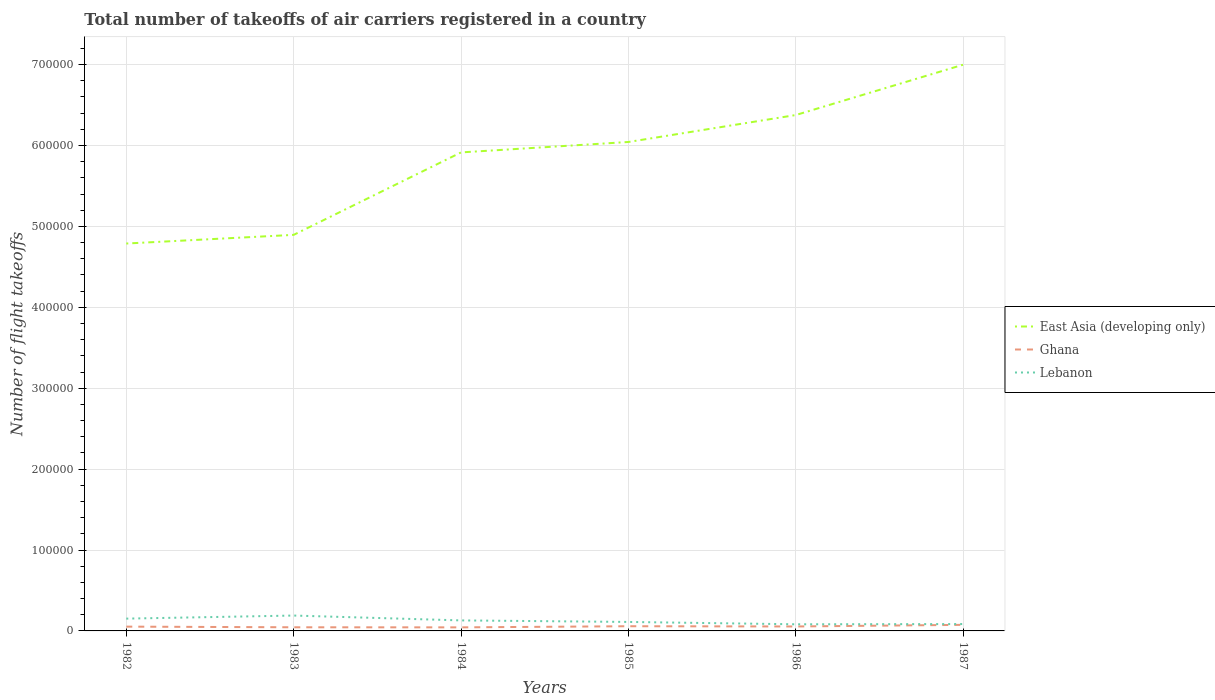Does the line corresponding to East Asia (developing only) intersect with the line corresponding to Lebanon?
Provide a short and direct response. No. Is the number of lines equal to the number of legend labels?
Give a very brief answer. Yes. Across all years, what is the maximum total number of flight takeoffs in East Asia (developing only)?
Ensure brevity in your answer.  4.79e+05. In which year was the total number of flight takeoffs in Lebanon maximum?
Give a very brief answer. 1986. What is the total total number of flight takeoffs in Ghana in the graph?
Your answer should be very brief. -3000. What is the difference between the highest and the second highest total number of flight takeoffs in East Asia (developing only)?
Offer a terse response. 2.21e+05. What is the difference between the highest and the lowest total number of flight takeoffs in Ghana?
Offer a very short reply. 2. Is the total number of flight takeoffs in Ghana strictly greater than the total number of flight takeoffs in East Asia (developing only) over the years?
Give a very brief answer. Yes. How many years are there in the graph?
Offer a very short reply. 6. What is the difference between two consecutive major ticks on the Y-axis?
Give a very brief answer. 1.00e+05. Are the values on the major ticks of Y-axis written in scientific E-notation?
Keep it short and to the point. No. Where does the legend appear in the graph?
Your answer should be very brief. Center right. How are the legend labels stacked?
Your response must be concise. Vertical. What is the title of the graph?
Offer a terse response. Total number of takeoffs of air carriers registered in a country. Does "Swaziland" appear as one of the legend labels in the graph?
Your answer should be compact. No. What is the label or title of the X-axis?
Your response must be concise. Years. What is the label or title of the Y-axis?
Keep it short and to the point. Number of flight takeoffs. What is the Number of flight takeoffs of East Asia (developing only) in 1982?
Keep it short and to the point. 4.79e+05. What is the Number of flight takeoffs of Ghana in 1982?
Make the answer very short. 5300. What is the Number of flight takeoffs in Lebanon in 1982?
Your answer should be very brief. 1.52e+04. What is the Number of flight takeoffs in East Asia (developing only) in 1983?
Provide a short and direct response. 4.90e+05. What is the Number of flight takeoffs in Ghana in 1983?
Provide a short and direct response. 4500. What is the Number of flight takeoffs in Lebanon in 1983?
Your response must be concise. 1.90e+04. What is the Number of flight takeoffs of East Asia (developing only) in 1984?
Keep it short and to the point. 5.91e+05. What is the Number of flight takeoffs in Ghana in 1984?
Provide a short and direct response. 4400. What is the Number of flight takeoffs of Lebanon in 1984?
Your answer should be compact. 1.30e+04. What is the Number of flight takeoffs in East Asia (developing only) in 1985?
Offer a very short reply. 6.04e+05. What is the Number of flight takeoffs in Ghana in 1985?
Your answer should be compact. 5800. What is the Number of flight takeoffs of Lebanon in 1985?
Give a very brief answer. 1.11e+04. What is the Number of flight takeoffs of East Asia (developing only) in 1986?
Your response must be concise. 6.38e+05. What is the Number of flight takeoffs of Ghana in 1986?
Provide a succinct answer. 5500. What is the Number of flight takeoffs in Lebanon in 1986?
Make the answer very short. 8200. What is the Number of flight takeoffs in East Asia (developing only) in 1987?
Your answer should be compact. 7.00e+05. What is the Number of flight takeoffs of Ghana in 1987?
Your answer should be compact. 7500. What is the Number of flight takeoffs of Lebanon in 1987?
Give a very brief answer. 8500. Across all years, what is the maximum Number of flight takeoffs of East Asia (developing only)?
Your response must be concise. 7.00e+05. Across all years, what is the maximum Number of flight takeoffs of Ghana?
Your response must be concise. 7500. Across all years, what is the maximum Number of flight takeoffs in Lebanon?
Your response must be concise. 1.90e+04. Across all years, what is the minimum Number of flight takeoffs in East Asia (developing only)?
Make the answer very short. 4.79e+05. Across all years, what is the minimum Number of flight takeoffs in Ghana?
Keep it short and to the point. 4400. Across all years, what is the minimum Number of flight takeoffs of Lebanon?
Ensure brevity in your answer.  8200. What is the total Number of flight takeoffs of East Asia (developing only) in the graph?
Offer a very short reply. 3.50e+06. What is the total Number of flight takeoffs of Ghana in the graph?
Offer a terse response. 3.30e+04. What is the total Number of flight takeoffs of Lebanon in the graph?
Keep it short and to the point. 7.50e+04. What is the difference between the Number of flight takeoffs in East Asia (developing only) in 1982 and that in 1983?
Keep it short and to the point. -1.07e+04. What is the difference between the Number of flight takeoffs of Ghana in 1982 and that in 1983?
Keep it short and to the point. 800. What is the difference between the Number of flight takeoffs of Lebanon in 1982 and that in 1983?
Give a very brief answer. -3800. What is the difference between the Number of flight takeoffs in East Asia (developing only) in 1982 and that in 1984?
Your response must be concise. -1.13e+05. What is the difference between the Number of flight takeoffs in Ghana in 1982 and that in 1984?
Provide a succinct answer. 900. What is the difference between the Number of flight takeoffs of Lebanon in 1982 and that in 1984?
Ensure brevity in your answer.  2200. What is the difference between the Number of flight takeoffs in East Asia (developing only) in 1982 and that in 1985?
Give a very brief answer. -1.26e+05. What is the difference between the Number of flight takeoffs of Ghana in 1982 and that in 1985?
Give a very brief answer. -500. What is the difference between the Number of flight takeoffs of Lebanon in 1982 and that in 1985?
Ensure brevity in your answer.  4100. What is the difference between the Number of flight takeoffs of East Asia (developing only) in 1982 and that in 1986?
Your answer should be compact. -1.59e+05. What is the difference between the Number of flight takeoffs in Ghana in 1982 and that in 1986?
Your answer should be compact. -200. What is the difference between the Number of flight takeoffs in Lebanon in 1982 and that in 1986?
Keep it short and to the point. 7000. What is the difference between the Number of flight takeoffs of East Asia (developing only) in 1982 and that in 1987?
Your response must be concise. -2.21e+05. What is the difference between the Number of flight takeoffs in Ghana in 1982 and that in 1987?
Offer a very short reply. -2200. What is the difference between the Number of flight takeoffs of Lebanon in 1982 and that in 1987?
Your response must be concise. 6700. What is the difference between the Number of flight takeoffs in East Asia (developing only) in 1983 and that in 1984?
Your response must be concise. -1.02e+05. What is the difference between the Number of flight takeoffs of Ghana in 1983 and that in 1984?
Provide a short and direct response. 100. What is the difference between the Number of flight takeoffs in Lebanon in 1983 and that in 1984?
Provide a short and direct response. 6000. What is the difference between the Number of flight takeoffs in East Asia (developing only) in 1983 and that in 1985?
Provide a short and direct response. -1.15e+05. What is the difference between the Number of flight takeoffs of Ghana in 1983 and that in 1985?
Your answer should be compact. -1300. What is the difference between the Number of flight takeoffs of Lebanon in 1983 and that in 1985?
Your response must be concise. 7900. What is the difference between the Number of flight takeoffs in East Asia (developing only) in 1983 and that in 1986?
Give a very brief answer. -1.48e+05. What is the difference between the Number of flight takeoffs in Ghana in 1983 and that in 1986?
Provide a short and direct response. -1000. What is the difference between the Number of flight takeoffs in Lebanon in 1983 and that in 1986?
Provide a short and direct response. 1.08e+04. What is the difference between the Number of flight takeoffs of East Asia (developing only) in 1983 and that in 1987?
Provide a succinct answer. -2.10e+05. What is the difference between the Number of flight takeoffs in Ghana in 1983 and that in 1987?
Offer a terse response. -3000. What is the difference between the Number of flight takeoffs in Lebanon in 1983 and that in 1987?
Give a very brief answer. 1.05e+04. What is the difference between the Number of flight takeoffs of East Asia (developing only) in 1984 and that in 1985?
Give a very brief answer. -1.29e+04. What is the difference between the Number of flight takeoffs in Ghana in 1984 and that in 1985?
Give a very brief answer. -1400. What is the difference between the Number of flight takeoffs of Lebanon in 1984 and that in 1985?
Offer a very short reply. 1900. What is the difference between the Number of flight takeoffs of East Asia (developing only) in 1984 and that in 1986?
Ensure brevity in your answer.  -4.62e+04. What is the difference between the Number of flight takeoffs in Ghana in 1984 and that in 1986?
Give a very brief answer. -1100. What is the difference between the Number of flight takeoffs in Lebanon in 1984 and that in 1986?
Offer a terse response. 4800. What is the difference between the Number of flight takeoffs in East Asia (developing only) in 1984 and that in 1987?
Provide a short and direct response. -1.08e+05. What is the difference between the Number of flight takeoffs in Ghana in 1984 and that in 1987?
Provide a succinct answer. -3100. What is the difference between the Number of flight takeoffs in Lebanon in 1984 and that in 1987?
Offer a terse response. 4500. What is the difference between the Number of flight takeoffs of East Asia (developing only) in 1985 and that in 1986?
Offer a very short reply. -3.33e+04. What is the difference between the Number of flight takeoffs in Ghana in 1985 and that in 1986?
Provide a succinct answer. 300. What is the difference between the Number of flight takeoffs of Lebanon in 1985 and that in 1986?
Your response must be concise. 2900. What is the difference between the Number of flight takeoffs of East Asia (developing only) in 1985 and that in 1987?
Provide a short and direct response. -9.55e+04. What is the difference between the Number of flight takeoffs in Ghana in 1985 and that in 1987?
Your answer should be very brief. -1700. What is the difference between the Number of flight takeoffs in Lebanon in 1985 and that in 1987?
Offer a very short reply. 2600. What is the difference between the Number of flight takeoffs in East Asia (developing only) in 1986 and that in 1987?
Give a very brief answer. -6.22e+04. What is the difference between the Number of flight takeoffs in Ghana in 1986 and that in 1987?
Your answer should be compact. -2000. What is the difference between the Number of flight takeoffs in Lebanon in 1986 and that in 1987?
Make the answer very short. -300. What is the difference between the Number of flight takeoffs of East Asia (developing only) in 1982 and the Number of flight takeoffs of Ghana in 1983?
Offer a terse response. 4.74e+05. What is the difference between the Number of flight takeoffs in East Asia (developing only) in 1982 and the Number of flight takeoffs in Lebanon in 1983?
Provide a succinct answer. 4.60e+05. What is the difference between the Number of flight takeoffs in Ghana in 1982 and the Number of flight takeoffs in Lebanon in 1983?
Offer a terse response. -1.37e+04. What is the difference between the Number of flight takeoffs of East Asia (developing only) in 1982 and the Number of flight takeoffs of Ghana in 1984?
Your response must be concise. 4.74e+05. What is the difference between the Number of flight takeoffs in East Asia (developing only) in 1982 and the Number of flight takeoffs in Lebanon in 1984?
Offer a terse response. 4.66e+05. What is the difference between the Number of flight takeoffs of Ghana in 1982 and the Number of flight takeoffs of Lebanon in 1984?
Ensure brevity in your answer.  -7700. What is the difference between the Number of flight takeoffs in East Asia (developing only) in 1982 and the Number of flight takeoffs in Ghana in 1985?
Keep it short and to the point. 4.73e+05. What is the difference between the Number of flight takeoffs in East Asia (developing only) in 1982 and the Number of flight takeoffs in Lebanon in 1985?
Offer a very short reply. 4.68e+05. What is the difference between the Number of flight takeoffs in Ghana in 1982 and the Number of flight takeoffs in Lebanon in 1985?
Your answer should be very brief. -5800. What is the difference between the Number of flight takeoffs in East Asia (developing only) in 1982 and the Number of flight takeoffs in Ghana in 1986?
Your answer should be compact. 4.73e+05. What is the difference between the Number of flight takeoffs of East Asia (developing only) in 1982 and the Number of flight takeoffs of Lebanon in 1986?
Provide a short and direct response. 4.71e+05. What is the difference between the Number of flight takeoffs in Ghana in 1982 and the Number of flight takeoffs in Lebanon in 1986?
Provide a short and direct response. -2900. What is the difference between the Number of flight takeoffs of East Asia (developing only) in 1982 and the Number of flight takeoffs of Ghana in 1987?
Keep it short and to the point. 4.71e+05. What is the difference between the Number of flight takeoffs of East Asia (developing only) in 1982 and the Number of flight takeoffs of Lebanon in 1987?
Give a very brief answer. 4.70e+05. What is the difference between the Number of flight takeoffs of Ghana in 1982 and the Number of flight takeoffs of Lebanon in 1987?
Your answer should be compact. -3200. What is the difference between the Number of flight takeoffs of East Asia (developing only) in 1983 and the Number of flight takeoffs of Ghana in 1984?
Give a very brief answer. 4.85e+05. What is the difference between the Number of flight takeoffs of East Asia (developing only) in 1983 and the Number of flight takeoffs of Lebanon in 1984?
Ensure brevity in your answer.  4.76e+05. What is the difference between the Number of flight takeoffs in Ghana in 1983 and the Number of flight takeoffs in Lebanon in 1984?
Make the answer very short. -8500. What is the difference between the Number of flight takeoffs in East Asia (developing only) in 1983 and the Number of flight takeoffs in Ghana in 1985?
Provide a succinct answer. 4.84e+05. What is the difference between the Number of flight takeoffs in East Asia (developing only) in 1983 and the Number of flight takeoffs in Lebanon in 1985?
Offer a terse response. 4.78e+05. What is the difference between the Number of flight takeoffs of Ghana in 1983 and the Number of flight takeoffs of Lebanon in 1985?
Offer a terse response. -6600. What is the difference between the Number of flight takeoffs of East Asia (developing only) in 1983 and the Number of flight takeoffs of Ghana in 1986?
Provide a succinct answer. 4.84e+05. What is the difference between the Number of flight takeoffs in East Asia (developing only) in 1983 and the Number of flight takeoffs in Lebanon in 1986?
Make the answer very short. 4.81e+05. What is the difference between the Number of flight takeoffs in Ghana in 1983 and the Number of flight takeoffs in Lebanon in 1986?
Your answer should be very brief. -3700. What is the difference between the Number of flight takeoffs of East Asia (developing only) in 1983 and the Number of flight takeoffs of Ghana in 1987?
Offer a terse response. 4.82e+05. What is the difference between the Number of flight takeoffs in East Asia (developing only) in 1983 and the Number of flight takeoffs in Lebanon in 1987?
Your answer should be very brief. 4.81e+05. What is the difference between the Number of flight takeoffs in Ghana in 1983 and the Number of flight takeoffs in Lebanon in 1987?
Provide a short and direct response. -4000. What is the difference between the Number of flight takeoffs in East Asia (developing only) in 1984 and the Number of flight takeoffs in Ghana in 1985?
Make the answer very short. 5.86e+05. What is the difference between the Number of flight takeoffs of East Asia (developing only) in 1984 and the Number of flight takeoffs of Lebanon in 1985?
Ensure brevity in your answer.  5.80e+05. What is the difference between the Number of flight takeoffs of Ghana in 1984 and the Number of flight takeoffs of Lebanon in 1985?
Offer a very short reply. -6700. What is the difference between the Number of flight takeoffs of East Asia (developing only) in 1984 and the Number of flight takeoffs of Ghana in 1986?
Offer a very short reply. 5.86e+05. What is the difference between the Number of flight takeoffs of East Asia (developing only) in 1984 and the Number of flight takeoffs of Lebanon in 1986?
Provide a succinct answer. 5.83e+05. What is the difference between the Number of flight takeoffs in Ghana in 1984 and the Number of flight takeoffs in Lebanon in 1986?
Give a very brief answer. -3800. What is the difference between the Number of flight takeoffs in East Asia (developing only) in 1984 and the Number of flight takeoffs in Ghana in 1987?
Provide a succinct answer. 5.84e+05. What is the difference between the Number of flight takeoffs of East Asia (developing only) in 1984 and the Number of flight takeoffs of Lebanon in 1987?
Ensure brevity in your answer.  5.83e+05. What is the difference between the Number of flight takeoffs in Ghana in 1984 and the Number of flight takeoffs in Lebanon in 1987?
Provide a short and direct response. -4100. What is the difference between the Number of flight takeoffs of East Asia (developing only) in 1985 and the Number of flight takeoffs of Ghana in 1986?
Make the answer very short. 5.99e+05. What is the difference between the Number of flight takeoffs of East Asia (developing only) in 1985 and the Number of flight takeoffs of Lebanon in 1986?
Keep it short and to the point. 5.96e+05. What is the difference between the Number of flight takeoffs of Ghana in 1985 and the Number of flight takeoffs of Lebanon in 1986?
Offer a very short reply. -2400. What is the difference between the Number of flight takeoffs in East Asia (developing only) in 1985 and the Number of flight takeoffs in Ghana in 1987?
Your response must be concise. 5.97e+05. What is the difference between the Number of flight takeoffs of East Asia (developing only) in 1985 and the Number of flight takeoffs of Lebanon in 1987?
Your answer should be very brief. 5.96e+05. What is the difference between the Number of flight takeoffs of Ghana in 1985 and the Number of flight takeoffs of Lebanon in 1987?
Keep it short and to the point. -2700. What is the difference between the Number of flight takeoffs of East Asia (developing only) in 1986 and the Number of flight takeoffs of Ghana in 1987?
Offer a terse response. 6.30e+05. What is the difference between the Number of flight takeoffs in East Asia (developing only) in 1986 and the Number of flight takeoffs in Lebanon in 1987?
Offer a very short reply. 6.29e+05. What is the difference between the Number of flight takeoffs of Ghana in 1986 and the Number of flight takeoffs of Lebanon in 1987?
Provide a short and direct response. -3000. What is the average Number of flight takeoffs in East Asia (developing only) per year?
Provide a succinct answer. 5.84e+05. What is the average Number of flight takeoffs of Ghana per year?
Provide a succinct answer. 5500. What is the average Number of flight takeoffs in Lebanon per year?
Give a very brief answer. 1.25e+04. In the year 1982, what is the difference between the Number of flight takeoffs in East Asia (developing only) and Number of flight takeoffs in Ghana?
Provide a succinct answer. 4.74e+05. In the year 1982, what is the difference between the Number of flight takeoffs of East Asia (developing only) and Number of flight takeoffs of Lebanon?
Ensure brevity in your answer.  4.64e+05. In the year 1982, what is the difference between the Number of flight takeoffs in Ghana and Number of flight takeoffs in Lebanon?
Your answer should be very brief. -9900. In the year 1983, what is the difference between the Number of flight takeoffs in East Asia (developing only) and Number of flight takeoffs in Ghana?
Your answer should be compact. 4.85e+05. In the year 1983, what is the difference between the Number of flight takeoffs of East Asia (developing only) and Number of flight takeoffs of Lebanon?
Offer a terse response. 4.70e+05. In the year 1983, what is the difference between the Number of flight takeoffs in Ghana and Number of flight takeoffs in Lebanon?
Keep it short and to the point. -1.45e+04. In the year 1984, what is the difference between the Number of flight takeoffs of East Asia (developing only) and Number of flight takeoffs of Ghana?
Offer a terse response. 5.87e+05. In the year 1984, what is the difference between the Number of flight takeoffs in East Asia (developing only) and Number of flight takeoffs in Lebanon?
Make the answer very short. 5.78e+05. In the year 1984, what is the difference between the Number of flight takeoffs of Ghana and Number of flight takeoffs of Lebanon?
Ensure brevity in your answer.  -8600. In the year 1985, what is the difference between the Number of flight takeoffs of East Asia (developing only) and Number of flight takeoffs of Ghana?
Make the answer very short. 5.98e+05. In the year 1985, what is the difference between the Number of flight takeoffs in East Asia (developing only) and Number of flight takeoffs in Lebanon?
Make the answer very short. 5.93e+05. In the year 1985, what is the difference between the Number of flight takeoffs in Ghana and Number of flight takeoffs in Lebanon?
Offer a terse response. -5300. In the year 1986, what is the difference between the Number of flight takeoffs in East Asia (developing only) and Number of flight takeoffs in Ghana?
Provide a succinct answer. 6.32e+05. In the year 1986, what is the difference between the Number of flight takeoffs in East Asia (developing only) and Number of flight takeoffs in Lebanon?
Offer a terse response. 6.29e+05. In the year 1986, what is the difference between the Number of flight takeoffs of Ghana and Number of flight takeoffs of Lebanon?
Offer a terse response. -2700. In the year 1987, what is the difference between the Number of flight takeoffs of East Asia (developing only) and Number of flight takeoffs of Ghana?
Provide a short and direct response. 6.92e+05. In the year 1987, what is the difference between the Number of flight takeoffs of East Asia (developing only) and Number of flight takeoffs of Lebanon?
Give a very brief answer. 6.91e+05. In the year 1987, what is the difference between the Number of flight takeoffs in Ghana and Number of flight takeoffs in Lebanon?
Ensure brevity in your answer.  -1000. What is the ratio of the Number of flight takeoffs of East Asia (developing only) in 1982 to that in 1983?
Keep it short and to the point. 0.98. What is the ratio of the Number of flight takeoffs in Ghana in 1982 to that in 1983?
Offer a very short reply. 1.18. What is the ratio of the Number of flight takeoffs of Lebanon in 1982 to that in 1983?
Keep it short and to the point. 0.8. What is the ratio of the Number of flight takeoffs of East Asia (developing only) in 1982 to that in 1984?
Keep it short and to the point. 0.81. What is the ratio of the Number of flight takeoffs of Ghana in 1982 to that in 1984?
Your response must be concise. 1.2. What is the ratio of the Number of flight takeoffs of Lebanon in 1982 to that in 1984?
Make the answer very short. 1.17. What is the ratio of the Number of flight takeoffs of East Asia (developing only) in 1982 to that in 1985?
Ensure brevity in your answer.  0.79. What is the ratio of the Number of flight takeoffs of Ghana in 1982 to that in 1985?
Keep it short and to the point. 0.91. What is the ratio of the Number of flight takeoffs in Lebanon in 1982 to that in 1985?
Your answer should be compact. 1.37. What is the ratio of the Number of flight takeoffs of East Asia (developing only) in 1982 to that in 1986?
Keep it short and to the point. 0.75. What is the ratio of the Number of flight takeoffs of Ghana in 1982 to that in 1986?
Offer a terse response. 0.96. What is the ratio of the Number of flight takeoffs in Lebanon in 1982 to that in 1986?
Provide a short and direct response. 1.85. What is the ratio of the Number of flight takeoffs of East Asia (developing only) in 1982 to that in 1987?
Provide a succinct answer. 0.68. What is the ratio of the Number of flight takeoffs in Ghana in 1982 to that in 1987?
Give a very brief answer. 0.71. What is the ratio of the Number of flight takeoffs of Lebanon in 1982 to that in 1987?
Provide a succinct answer. 1.79. What is the ratio of the Number of flight takeoffs in East Asia (developing only) in 1983 to that in 1984?
Make the answer very short. 0.83. What is the ratio of the Number of flight takeoffs in Ghana in 1983 to that in 1984?
Provide a succinct answer. 1.02. What is the ratio of the Number of flight takeoffs of Lebanon in 1983 to that in 1984?
Ensure brevity in your answer.  1.46. What is the ratio of the Number of flight takeoffs in East Asia (developing only) in 1983 to that in 1985?
Offer a terse response. 0.81. What is the ratio of the Number of flight takeoffs in Ghana in 1983 to that in 1985?
Your response must be concise. 0.78. What is the ratio of the Number of flight takeoffs of Lebanon in 1983 to that in 1985?
Make the answer very short. 1.71. What is the ratio of the Number of flight takeoffs in East Asia (developing only) in 1983 to that in 1986?
Your answer should be very brief. 0.77. What is the ratio of the Number of flight takeoffs in Ghana in 1983 to that in 1986?
Your answer should be compact. 0.82. What is the ratio of the Number of flight takeoffs of Lebanon in 1983 to that in 1986?
Offer a terse response. 2.32. What is the ratio of the Number of flight takeoffs in East Asia (developing only) in 1983 to that in 1987?
Keep it short and to the point. 0.7. What is the ratio of the Number of flight takeoffs in Ghana in 1983 to that in 1987?
Make the answer very short. 0.6. What is the ratio of the Number of flight takeoffs of Lebanon in 1983 to that in 1987?
Your response must be concise. 2.24. What is the ratio of the Number of flight takeoffs of East Asia (developing only) in 1984 to that in 1985?
Ensure brevity in your answer.  0.98. What is the ratio of the Number of flight takeoffs in Ghana in 1984 to that in 1985?
Provide a succinct answer. 0.76. What is the ratio of the Number of flight takeoffs of Lebanon in 1984 to that in 1985?
Ensure brevity in your answer.  1.17. What is the ratio of the Number of flight takeoffs of East Asia (developing only) in 1984 to that in 1986?
Provide a short and direct response. 0.93. What is the ratio of the Number of flight takeoffs of Ghana in 1984 to that in 1986?
Your answer should be very brief. 0.8. What is the ratio of the Number of flight takeoffs of Lebanon in 1984 to that in 1986?
Ensure brevity in your answer.  1.59. What is the ratio of the Number of flight takeoffs in East Asia (developing only) in 1984 to that in 1987?
Keep it short and to the point. 0.85. What is the ratio of the Number of flight takeoffs in Ghana in 1984 to that in 1987?
Your answer should be compact. 0.59. What is the ratio of the Number of flight takeoffs in Lebanon in 1984 to that in 1987?
Offer a terse response. 1.53. What is the ratio of the Number of flight takeoffs of East Asia (developing only) in 1985 to that in 1986?
Offer a very short reply. 0.95. What is the ratio of the Number of flight takeoffs of Ghana in 1985 to that in 1986?
Provide a succinct answer. 1.05. What is the ratio of the Number of flight takeoffs of Lebanon in 1985 to that in 1986?
Ensure brevity in your answer.  1.35. What is the ratio of the Number of flight takeoffs in East Asia (developing only) in 1985 to that in 1987?
Ensure brevity in your answer.  0.86. What is the ratio of the Number of flight takeoffs in Ghana in 1985 to that in 1987?
Your answer should be very brief. 0.77. What is the ratio of the Number of flight takeoffs of Lebanon in 1985 to that in 1987?
Provide a short and direct response. 1.31. What is the ratio of the Number of flight takeoffs in East Asia (developing only) in 1986 to that in 1987?
Your response must be concise. 0.91. What is the ratio of the Number of flight takeoffs in Ghana in 1986 to that in 1987?
Your response must be concise. 0.73. What is the ratio of the Number of flight takeoffs in Lebanon in 1986 to that in 1987?
Provide a succinct answer. 0.96. What is the difference between the highest and the second highest Number of flight takeoffs in East Asia (developing only)?
Ensure brevity in your answer.  6.22e+04. What is the difference between the highest and the second highest Number of flight takeoffs of Ghana?
Give a very brief answer. 1700. What is the difference between the highest and the second highest Number of flight takeoffs in Lebanon?
Give a very brief answer. 3800. What is the difference between the highest and the lowest Number of flight takeoffs in East Asia (developing only)?
Provide a succinct answer. 2.21e+05. What is the difference between the highest and the lowest Number of flight takeoffs in Ghana?
Ensure brevity in your answer.  3100. What is the difference between the highest and the lowest Number of flight takeoffs in Lebanon?
Provide a succinct answer. 1.08e+04. 